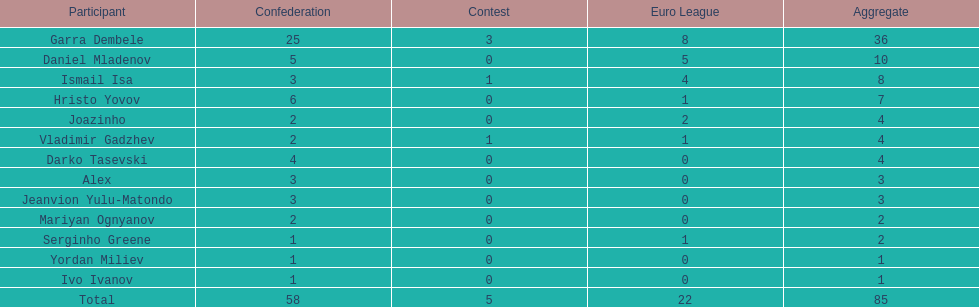Which players have at least 4 in the europa league? Garra Dembele, Daniel Mladenov, Ismail Isa. 